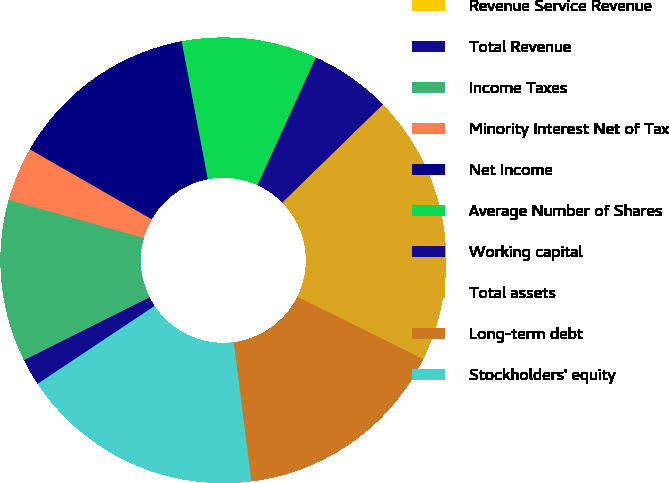Convert chart to OTSL. <chart><loc_0><loc_0><loc_500><loc_500><pie_chart><fcel>Revenue Service Revenue<fcel>Total Revenue<fcel>Income Taxes<fcel>Minority Interest Net of Tax<fcel>Net Income<fcel>Average Number of Shares<fcel>Working capital<fcel>Total assets<fcel>Long-term debt<fcel>Stockholders' equity<nl><fcel>0.0%<fcel>1.96%<fcel>11.76%<fcel>3.92%<fcel>13.72%<fcel>9.8%<fcel>5.88%<fcel>19.61%<fcel>15.69%<fcel>17.65%<nl></chart> 